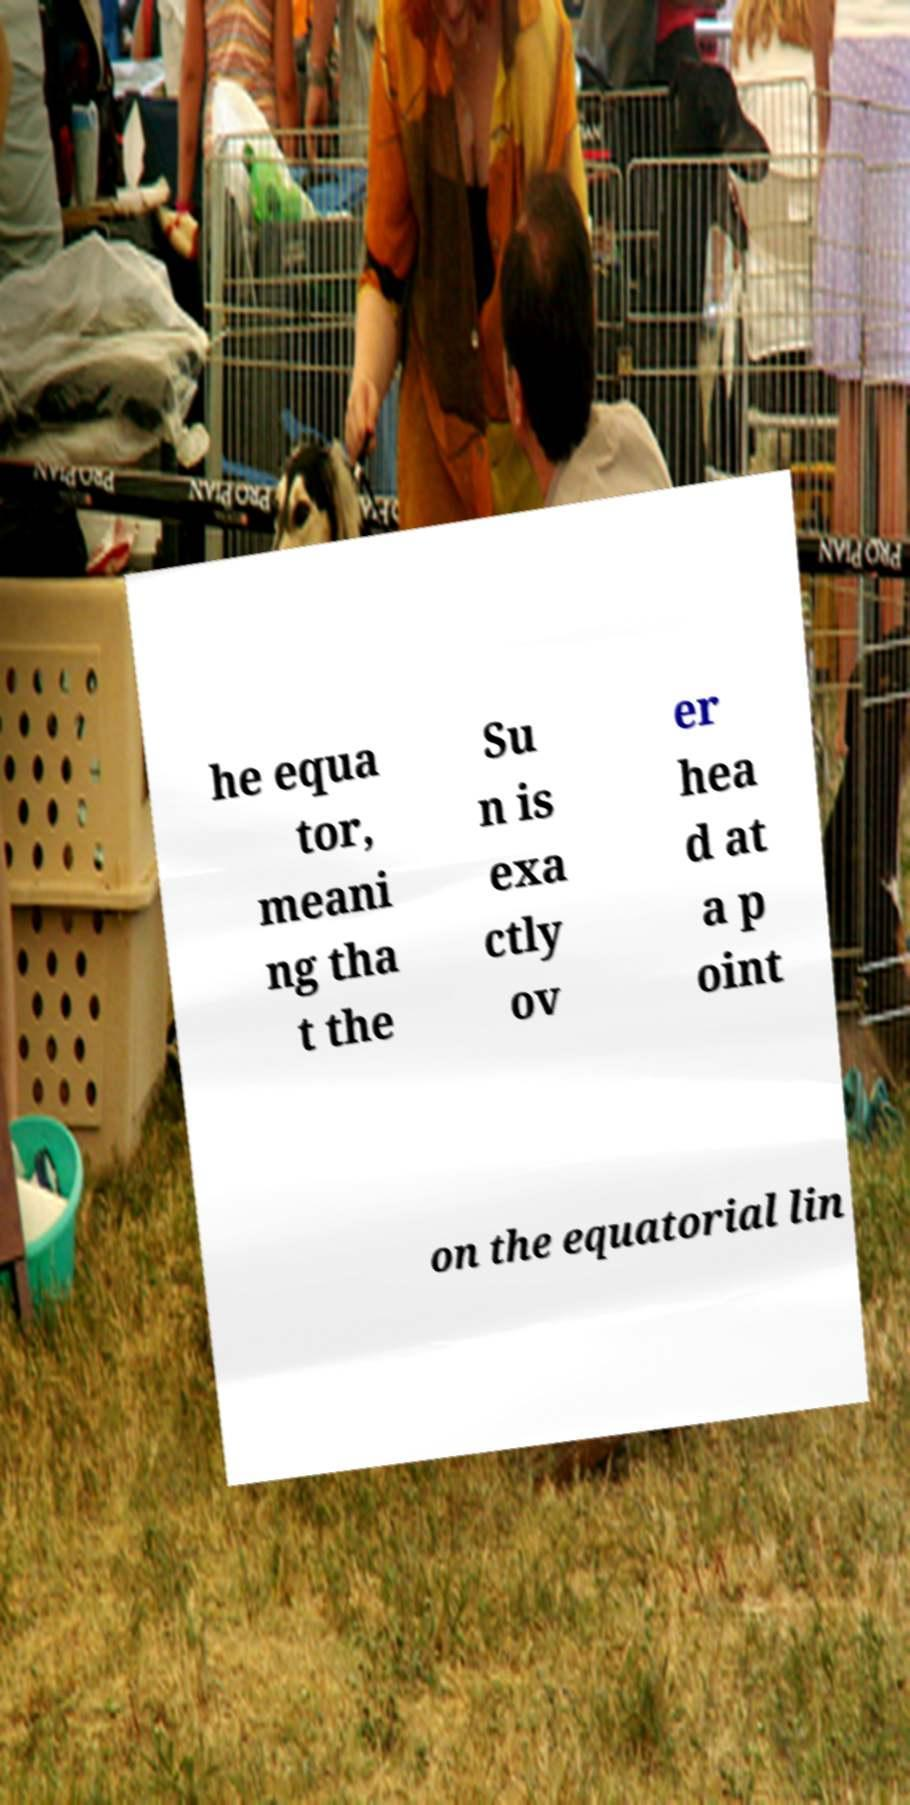Please read and relay the text visible in this image. What does it say? he equa tor, meani ng tha t the Su n is exa ctly ov er hea d at a p oint on the equatorial lin 